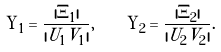Convert formula to latex. <formula><loc_0><loc_0><loc_500><loc_500>\Upsilon _ { 1 } = \frac { | \Xi _ { 1 } | } { | U _ { 1 } V _ { 1 } | } , \quad \Upsilon _ { 2 } = \frac { | \Xi _ { 2 } | } { | U _ { 2 } V _ { 2 } | } .</formula> 